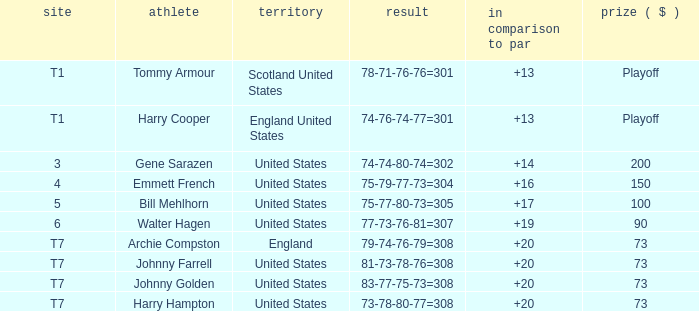Would you mind parsing the complete table? {'header': ['site', 'athlete', 'territory', 'result', 'in comparison to par', 'prize ( $ )'], 'rows': [['T1', 'Tommy Armour', 'Scotland United States', '78-71-76-76=301', '+13', 'Playoff'], ['T1', 'Harry Cooper', 'England United States', '74-76-74-77=301', '+13', 'Playoff'], ['3', 'Gene Sarazen', 'United States', '74-74-80-74=302', '+14', '200'], ['4', 'Emmett French', 'United States', '75-79-77-73=304', '+16', '150'], ['5', 'Bill Mehlhorn', 'United States', '75-77-80-73=305', '+17', '100'], ['6', 'Walter Hagen', 'United States', '77-73-76-81=307', '+19', '90'], ['T7', 'Archie Compston', 'England', '79-74-76-79=308', '+20', '73'], ['T7', 'Johnny Farrell', 'United States', '81-73-78-76=308', '+20', '73'], ['T7', 'Johnny Golden', 'United States', '83-77-75-73=308', '+20', '73'], ['T7', 'Harry Hampton', 'United States', '73-78-80-77=308', '+20', '73']]} What is the ranking when Archie Compston is the player and the money is $73? T7. 